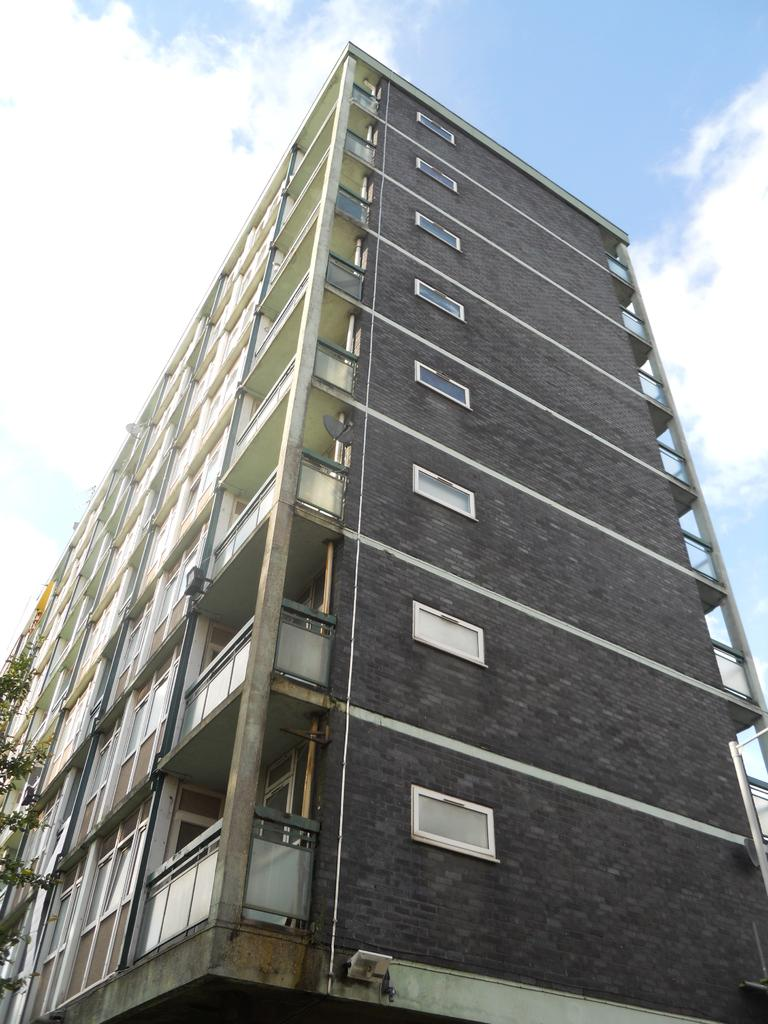What type of structure is in the picture? There is a building in the picture. What features can be seen on the building? The building has windows and balconies. What is located at the left side of the picture? There is a tree at the left side of the picture. How would you describe the sky in the image? The sky is clear in the image. How many combs are visible on the balconies of the building in the image? There are no combs visible on the balconies of the building in the image. Is there any coal being used to heat the building in the image? There is no indication of coal or any heating source in the image. Can you see any clams on the tree in the image? There are no clams visible on the tree in the image. 